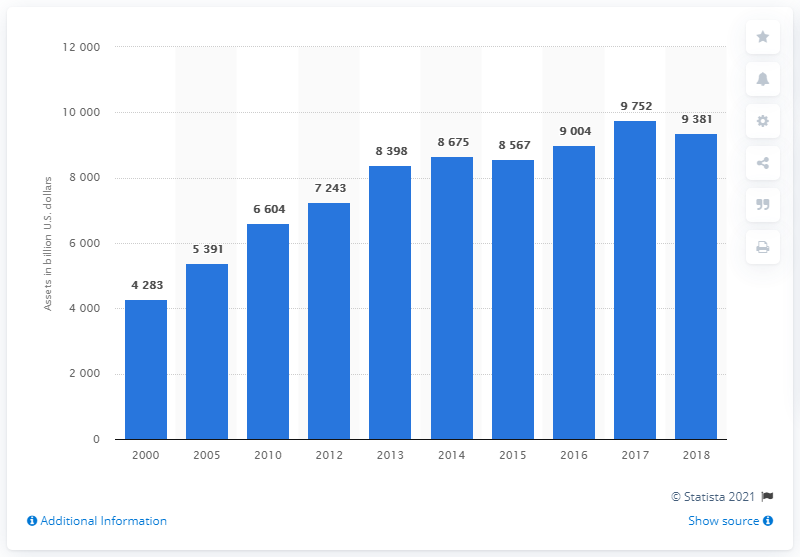Specify some key components in this picture. The value of financial assets held by private pension funds in the United States in the year 2010 was approximately 6604 billion U.S. dollars. From 2000 to 2018, the value of private pension funds' financial assets in the United States consistently exceeded 9000 billion U.S. dollars for at least 3 years. The total amount of private pension funds in the United States in 2018 was approximately 93,810 dollars. 